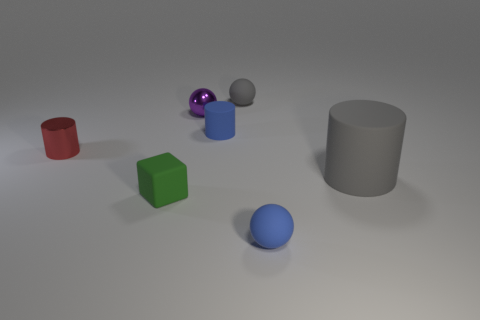What is the size of the ball that is on the right side of the small blue cylinder and behind the tiny blue ball?
Offer a terse response. Small. There is a tiny matte thing that is both to the right of the tiny cube and to the left of the gray ball; what shape is it?
Provide a succinct answer. Cylinder. Are there any tiny blocks that are right of the blue object behind the rubber object that is in front of the tiny matte block?
Offer a terse response. No. How many things are small blue things behind the small red cylinder or balls that are on the right side of the shiny sphere?
Your answer should be very brief. 3. Is the cylinder to the right of the blue ball made of the same material as the green block?
Your answer should be compact. Yes. There is a small thing that is to the left of the tiny matte cylinder and behind the red cylinder; what material is it?
Your answer should be very brief. Metal. The rubber cylinder that is left of the blue matte object that is in front of the tiny blue matte cylinder is what color?
Provide a short and direct response. Blue. What is the material of the other blue object that is the same shape as the large rubber thing?
Provide a short and direct response. Rubber. What color is the tiny matte ball behind the cylinder in front of the tiny metal object on the left side of the small cube?
Ensure brevity in your answer.  Gray. What number of objects are gray shiny cylinders or blue spheres?
Your answer should be compact. 1. 